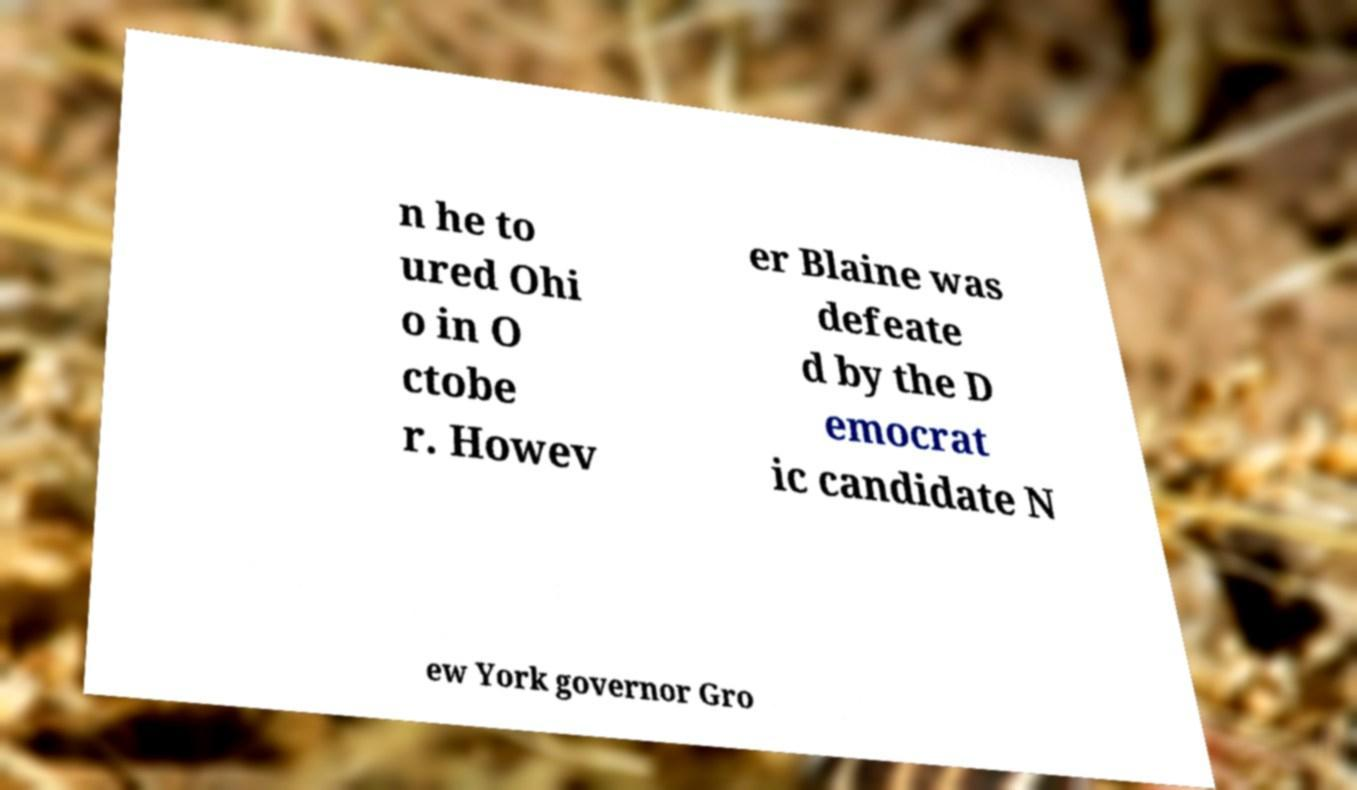What messages or text are displayed in this image? I need them in a readable, typed format. n he to ured Ohi o in O ctobe r. Howev er Blaine was defeate d by the D emocrat ic candidate N ew York governor Gro 